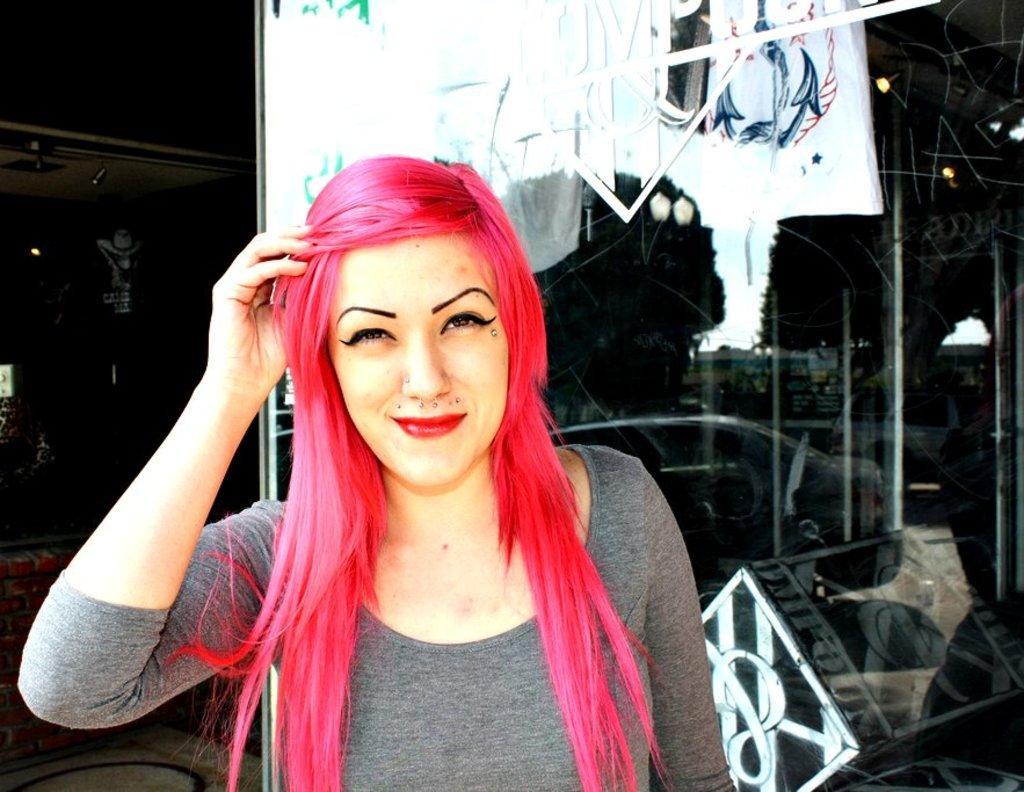Can you describe this image briefly? In this picture we can see a woman is smiling in the front, on the right side there is a glass, from the glass we can see metal rods and lights, we can see reflection of a car on the glass. 